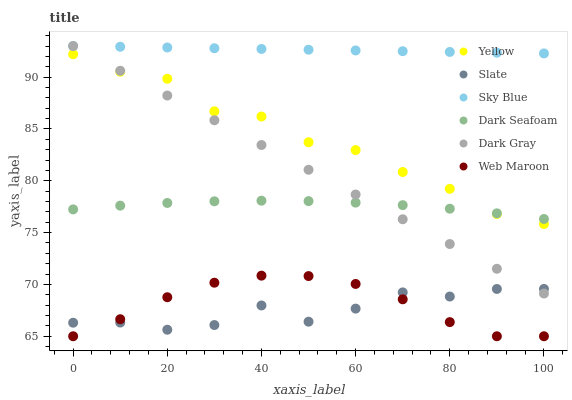Does Slate have the minimum area under the curve?
Answer yes or no. Yes. Does Sky Blue have the maximum area under the curve?
Answer yes or no. Yes. Does Web Maroon have the minimum area under the curve?
Answer yes or no. No. Does Web Maroon have the maximum area under the curve?
Answer yes or no. No. Is Sky Blue the smoothest?
Answer yes or no. Yes. Is Yellow the roughest?
Answer yes or no. Yes. Is Web Maroon the smoothest?
Answer yes or no. No. Is Web Maroon the roughest?
Answer yes or no. No. Does Web Maroon have the lowest value?
Answer yes or no. Yes. Does Yellow have the lowest value?
Answer yes or no. No. Does Sky Blue have the highest value?
Answer yes or no. Yes. Does Web Maroon have the highest value?
Answer yes or no. No. Is Dark Seafoam less than Sky Blue?
Answer yes or no. Yes. Is Sky Blue greater than Slate?
Answer yes or no. Yes. Does Dark Seafoam intersect Yellow?
Answer yes or no. Yes. Is Dark Seafoam less than Yellow?
Answer yes or no. No. Is Dark Seafoam greater than Yellow?
Answer yes or no. No. Does Dark Seafoam intersect Sky Blue?
Answer yes or no. No. 